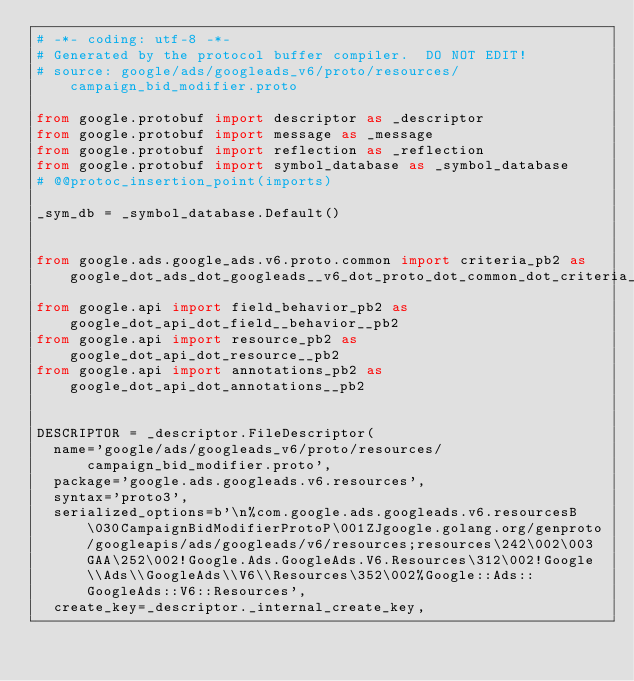Convert code to text. <code><loc_0><loc_0><loc_500><loc_500><_Python_># -*- coding: utf-8 -*-
# Generated by the protocol buffer compiler.  DO NOT EDIT!
# source: google/ads/googleads_v6/proto/resources/campaign_bid_modifier.proto

from google.protobuf import descriptor as _descriptor
from google.protobuf import message as _message
from google.protobuf import reflection as _reflection
from google.protobuf import symbol_database as _symbol_database
# @@protoc_insertion_point(imports)

_sym_db = _symbol_database.Default()


from google.ads.google_ads.v6.proto.common import criteria_pb2 as google_dot_ads_dot_googleads__v6_dot_proto_dot_common_dot_criteria__pb2
from google.api import field_behavior_pb2 as google_dot_api_dot_field__behavior__pb2
from google.api import resource_pb2 as google_dot_api_dot_resource__pb2
from google.api import annotations_pb2 as google_dot_api_dot_annotations__pb2


DESCRIPTOR = _descriptor.FileDescriptor(
  name='google/ads/googleads_v6/proto/resources/campaign_bid_modifier.proto',
  package='google.ads.googleads.v6.resources',
  syntax='proto3',
  serialized_options=b'\n%com.google.ads.googleads.v6.resourcesB\030CampaignBidModifierProtoP\001ZJgoogle.golang.org/genproto/googleapis/ads/googleads/v6/resources;resources\242\002\003GAA\252\002!Google.Ads.GoogleAds.V6.Resources\312\002!Google\\Ads\\GoogleAds\\V6\\Resources\352\002%Google::Ads::GoogleAds::V6::Resources',
  create_key=_descriptor._internal_create_key,</code> 